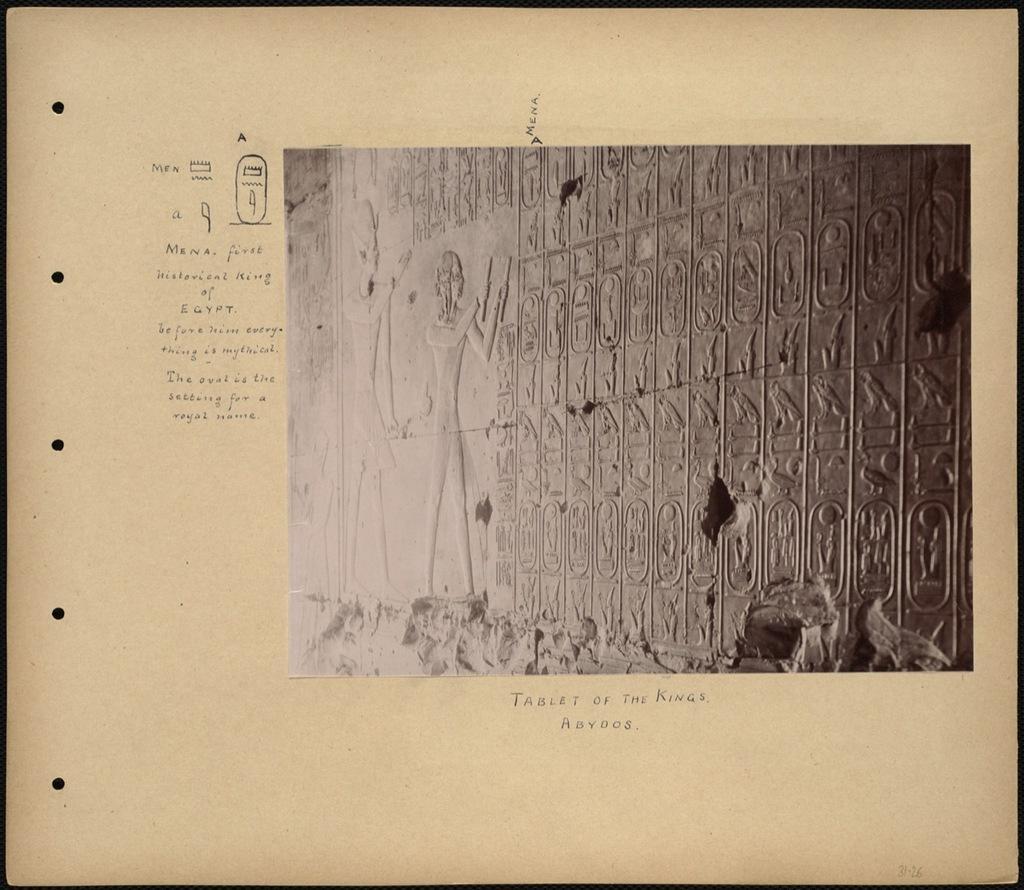In one or two sentences, can you explain what this image depicts? In this image there is a wall, on the wall there is one board and some text. 